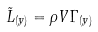Convert formula to latex. <formula><loc_0><loc_0><loc_500><loc_500>\tilde { L } _ { ( y ) } = \rho V \Gamma _ { ( y ) }</formula> 